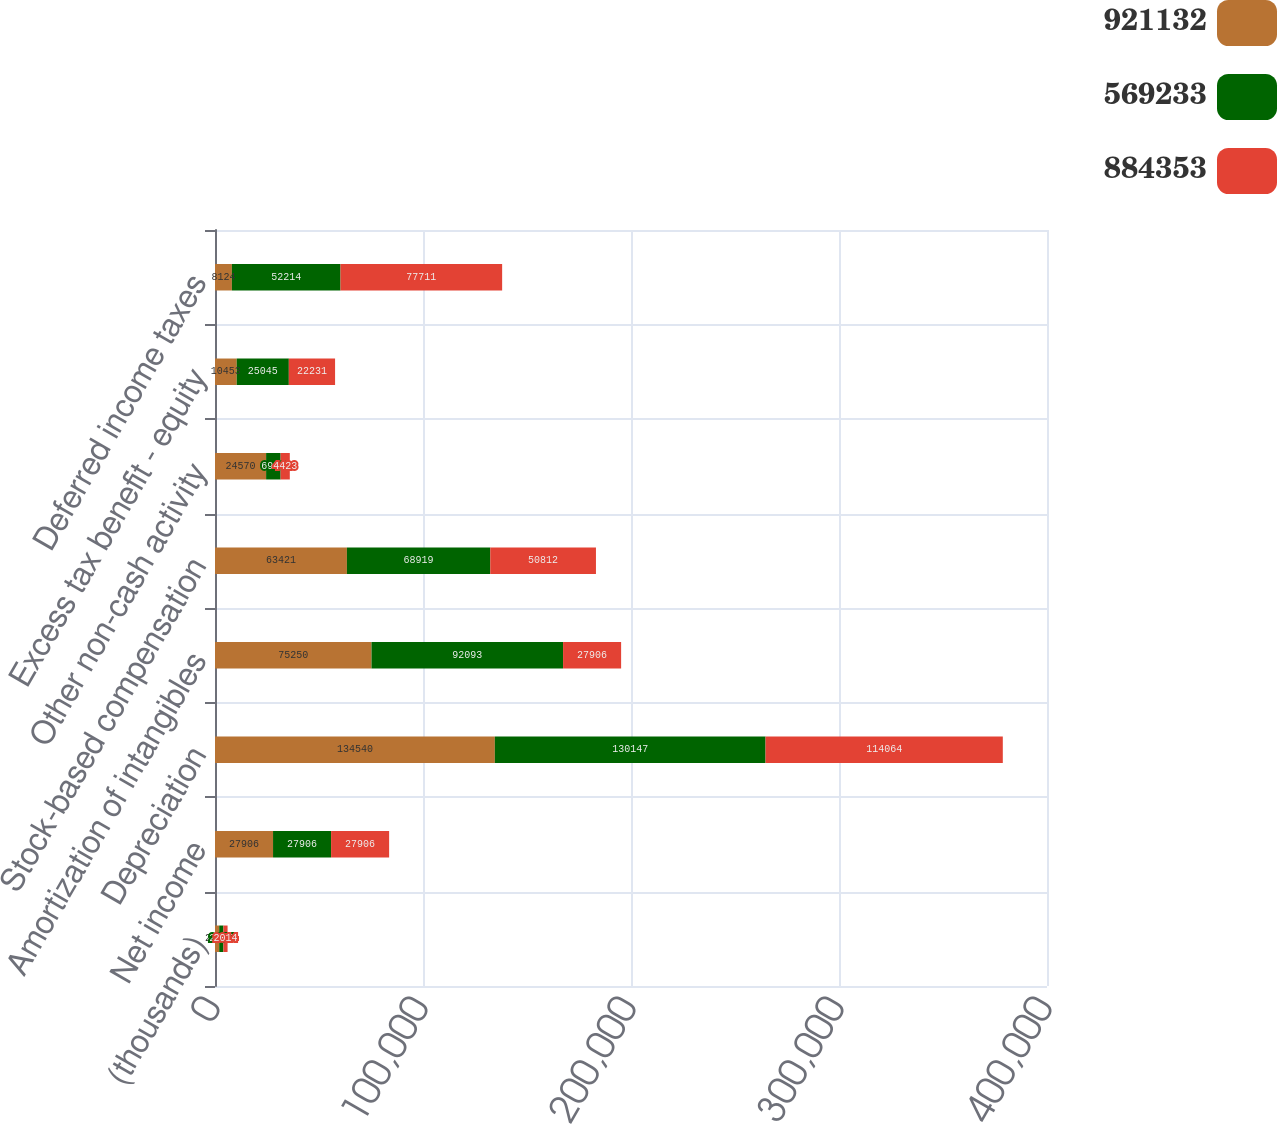Convert chart. <chart><loc_0><loc_0><loc_500><loc_500><stacked_bar_chart><ecel><fcel>(thousands)<fcel>Net income<fcel>Depreciation<fcel>Amortization of intangibles<fcel>Stock-based compensation<fcel>Other non-cash activity<fcel>Excess tax benefit - equity<fcel>Deferred income taxes<nl><fcel>921132<fcel>2016<fcel>27906<fcel>134540<fcel>75250<fcel>63421<fcel>24570<fcel>10453<fcel>8124<nl><fcel>569233<fcel>2015<fcel>27906<fcel>130147<fcel>92093<fcel>68919<fcel>6974<fcel>25045<fcel>52214<nl><fcel>884353<fcel>2014<fcel>27906<fcel>114064<fcel>27906<fcel>50812<fcel>4423<fcel>22231<fcel>77711<nl></chart> 